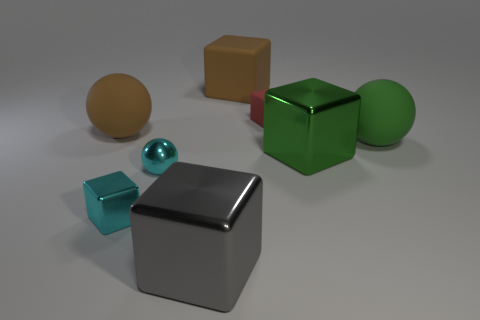Subtract all large green balls. How many balls are left? 2 Add 1 big brown cubes. How many objects exist? 9 Subtract 1 spheres. How many spheres are left? 2 Subtract all green spheres. How many spheres are left? 2 Subtract all spheres. How many objects are left? 5 Subtract all gray cubes. Subtract all brown things. How many objects are left? 5 Add 5 tiny red blocks. How many tiny red blocks are left? 6 Add 2 matte spheres. How many matte spheres exist? 4 Subtract 1 cyan spheres. How many objects are left? 7 Subtract all blue balls. Subtract all red cylinders. How many balls are left? 3 